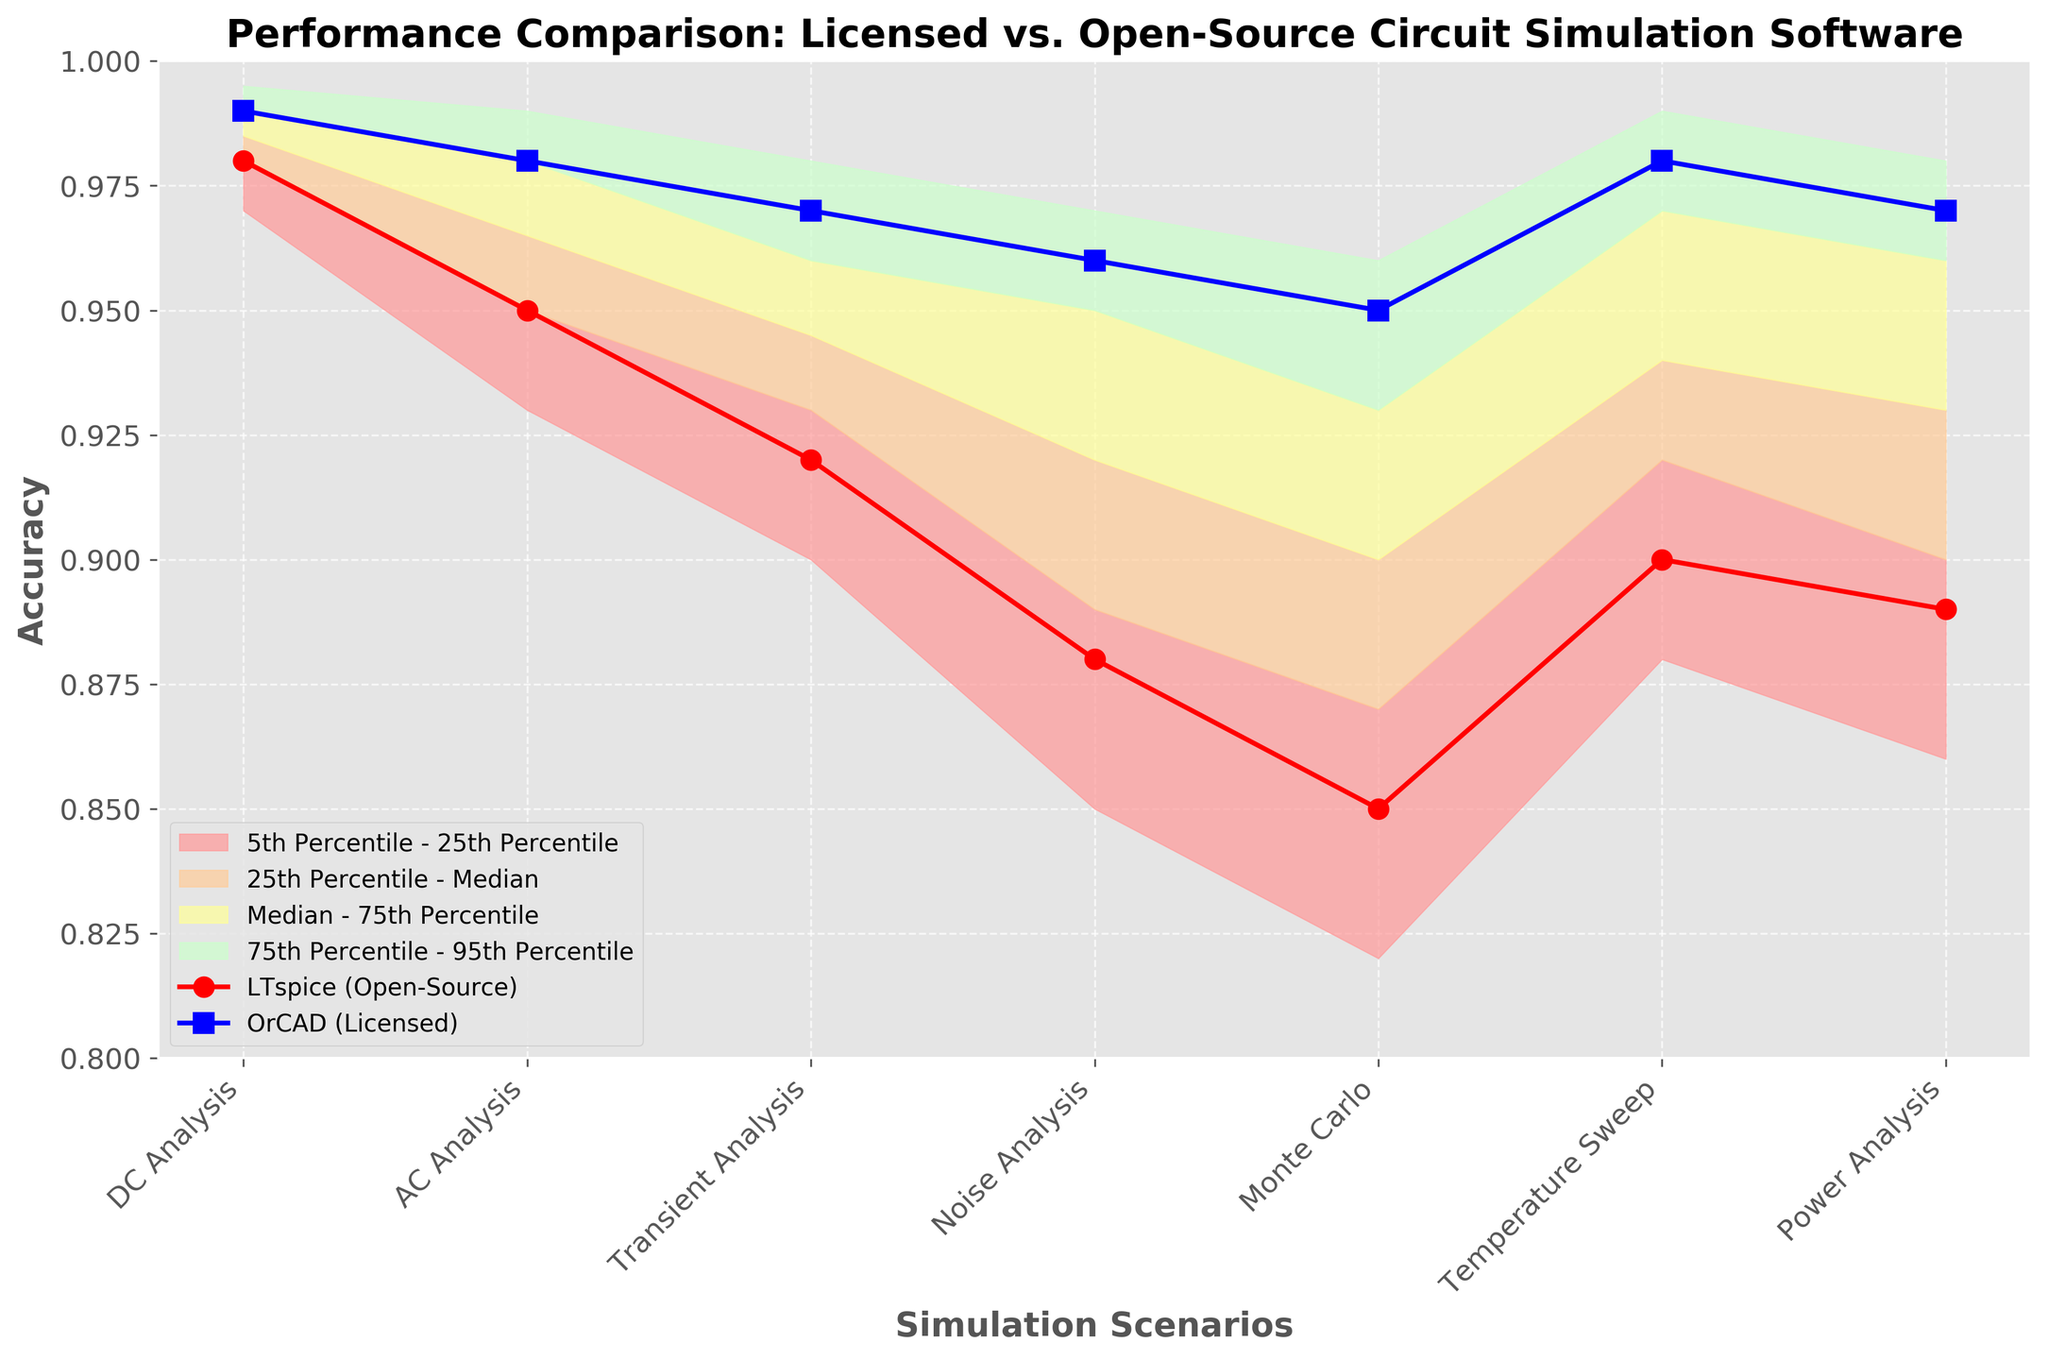What is the title of the chart? The title is prominently displayed at the top of the chart. It reads: "Performance Comparison: Licensed vs. Open-Source Circuit Simulation Software."
Answer: Performance Comparison: Licensed vs. Open-Source Circuit Simulation Software How many simulation scenarios are compared in the chart? The x-axis lists all the simulation scenarios. Counting them reveals there are seven scenarios.
Answer: Seven What is the accuracy value for LTspice in the Temperature Sweep scenario? Find the data point for LTspice (open-source) in the Temperature Sweep scenario. The plot shows it at the intersection with the corresponding y-value.
Answer: 0.90 In which scenario is the accuracy gap between LTspice and OrCAD the smallest? Compare the differences between LTspice and OrCAD across all scenarios. The smallest difference is observed in DC Analysis.
Answer: DC Analysis Which percentile range is highlighted in light blue? The colors in the fan chart are used to distinguish different percentile ranges. The light blue color corresponds to the range between the 75th and 95th percentiles as indicated by the legend.
Answer: 75th to 95th percentiles What is the median accuracy value in the Monte Carlo scenario? Locate the Monte Carlo scenario and identify the corresponding median value from the fan chart. The plot marks this value along the median line.
Answer: 0.90 Are the accuracy values of OrCAD consistently higher than LTspice in all scenarios? Examine the accuracy points for both OrCAD and LTspice across all scenarios. OrCAD consistently shows higher accuracy values than LTspice.
Answer: Yes What is the median accuracy value across all scenarios for OrCAD? The median values for each scenario can be read directly from the y-axis alignments for OrCAD (Licensed). Summing these values: 0.99 + 0.98 + 0.97 + 0.96 + 0.95 + 0.98 + 0.97 and dividing by the number of scenarios (7), results in the median value. Detailed explanation: (0.99+0.98+0.97+0.96+0.95+0.98+0.97) / 7 = 6.80 / 7 = ~0.971.
Answer: 0.97 Which scenario shows the most considerable disparity in accuracy between the 5th and 95th percentiles? By referring to the fan chart, compare the vertical distances between the 5th and 95th percentiles for each scenario. Noise Analysis exhibits the largest disparity.
Answer: Noise Analysis 